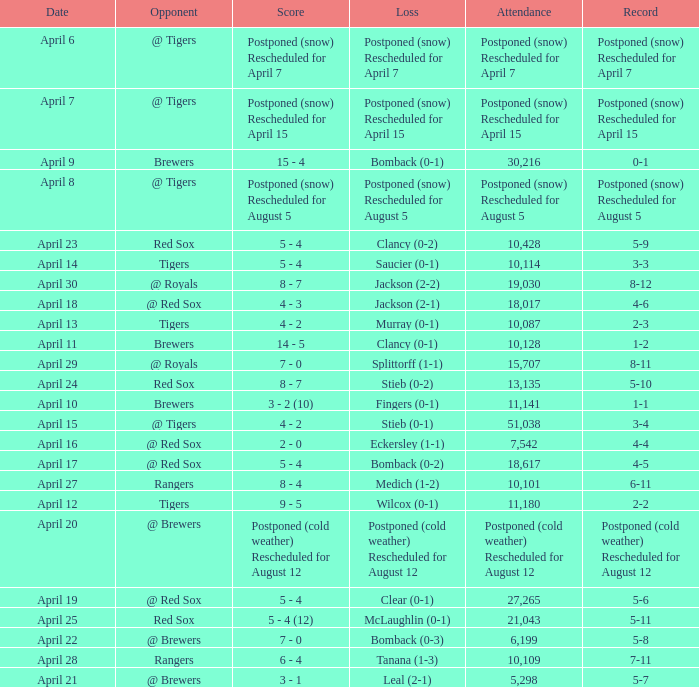What is the record for the game with an attendance of 11,141? 1-1. 